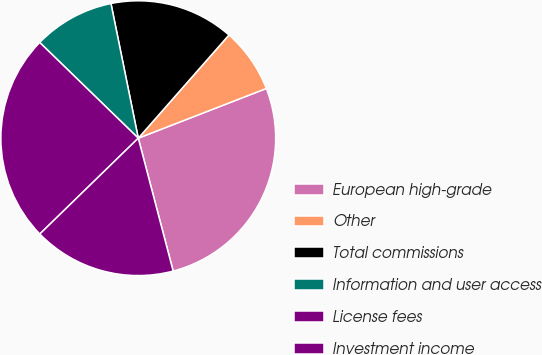Convert chart. <chart><loc_0><loc_0><loc_500><loc_500><pie_chart><fcel>European high-grade<fcel>Other<fcel>Total commissions<fcel>Information and user access<fcel>License fees<fcel>Investment income<nl><fcel>26.81%<fcel>7.63%<fcel>14.66%<fcel>9.55%<fcel>24.55%<fcel>16.8%<nl></chart> 